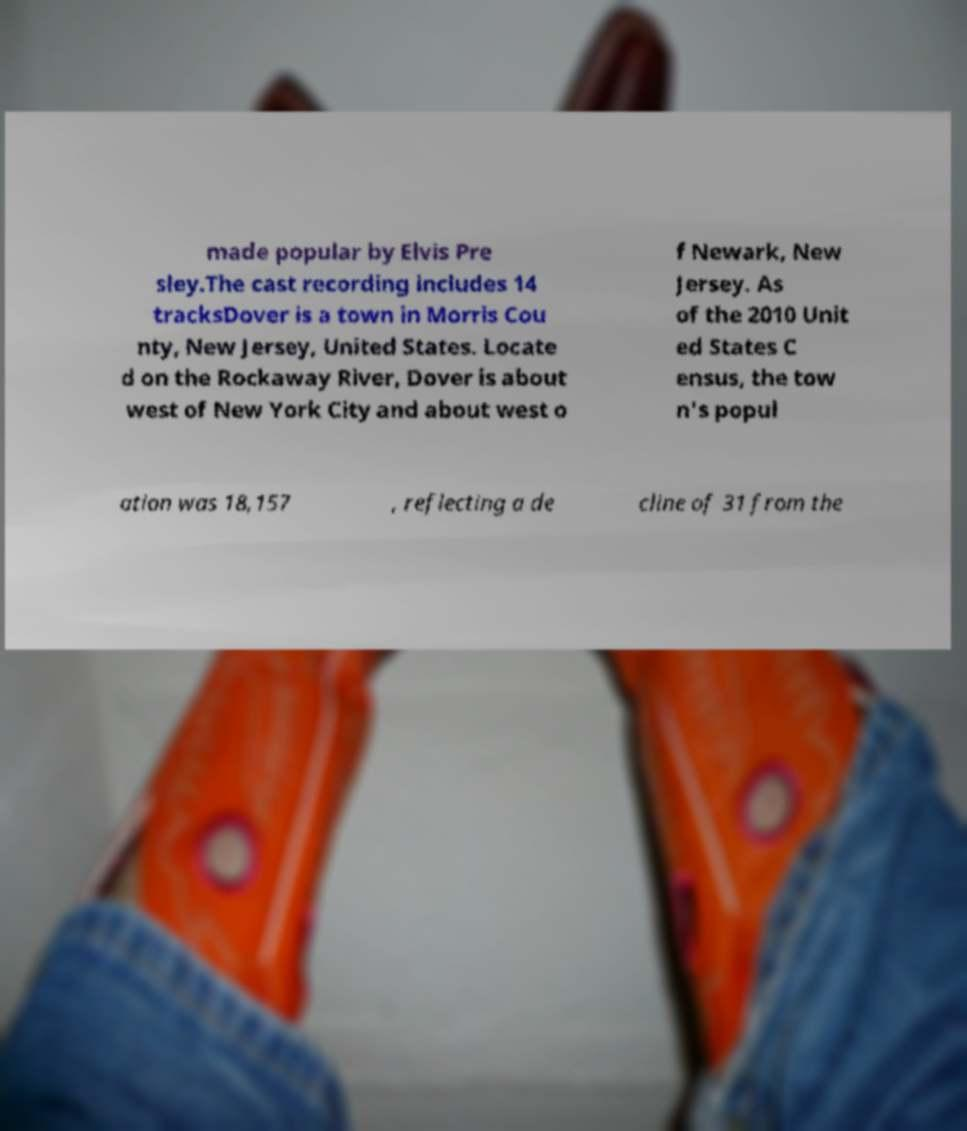Can you accurately transcribe the text from the provided image for me? made popular by Elvis Pre sley.The cast recording includes 14 tracksDover is a town in Morris Cou nty, New Jersey, United States. Locate d on the Rockaway River, Dover is about west of New York City and about west o f Newark, New Jersey. As of the 2010 Unit ed States C ensus, the tow n's popul ation was 18,157 , reflecting a de cline of 31 from the 